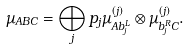Convert formula to latex. <formula><loc_0><loc_0><loc_500><loc_500>\mu _ { A B C } = \bigoplus _ { j } p _ { j } \mu ^ { ( j ) } _ { A b _ { j } ^ { L } } \otimes \mu ^ { ( j ) } _ { b _ { j } ^ { R } C } .</formula> 